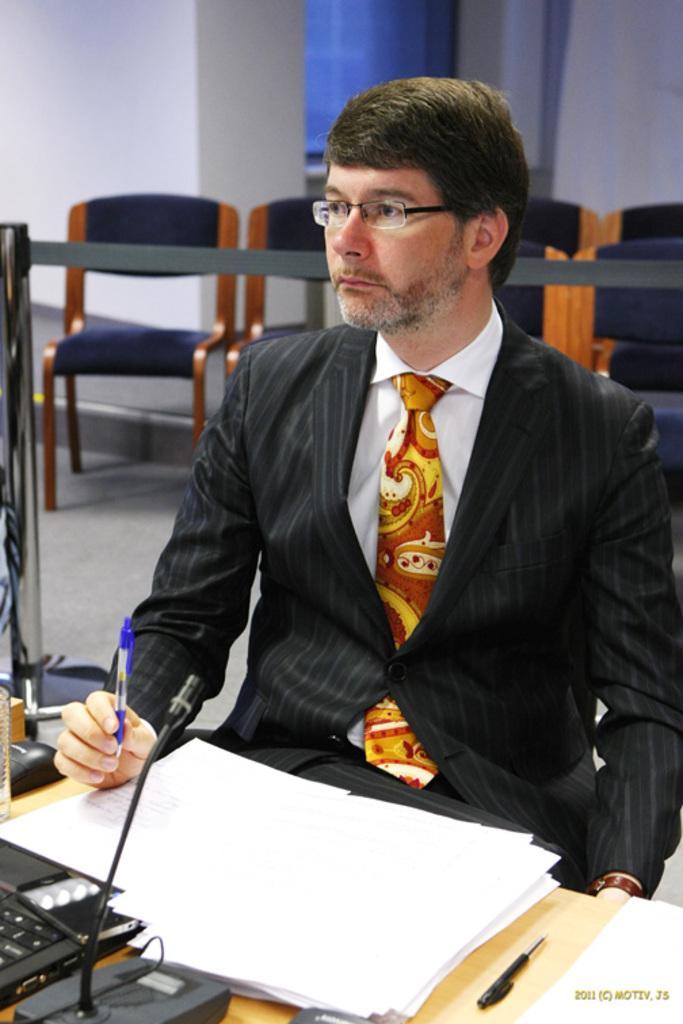Can you describe this image briefly? In this image there is a person holding a pen is wearing suit and tie is sitting on chair. On the table there are few papers. On top of table there is a microphone, aside to that there is a laptop and there is mouse. At back to the person there are few chairs. Background of the image is having a wall. 